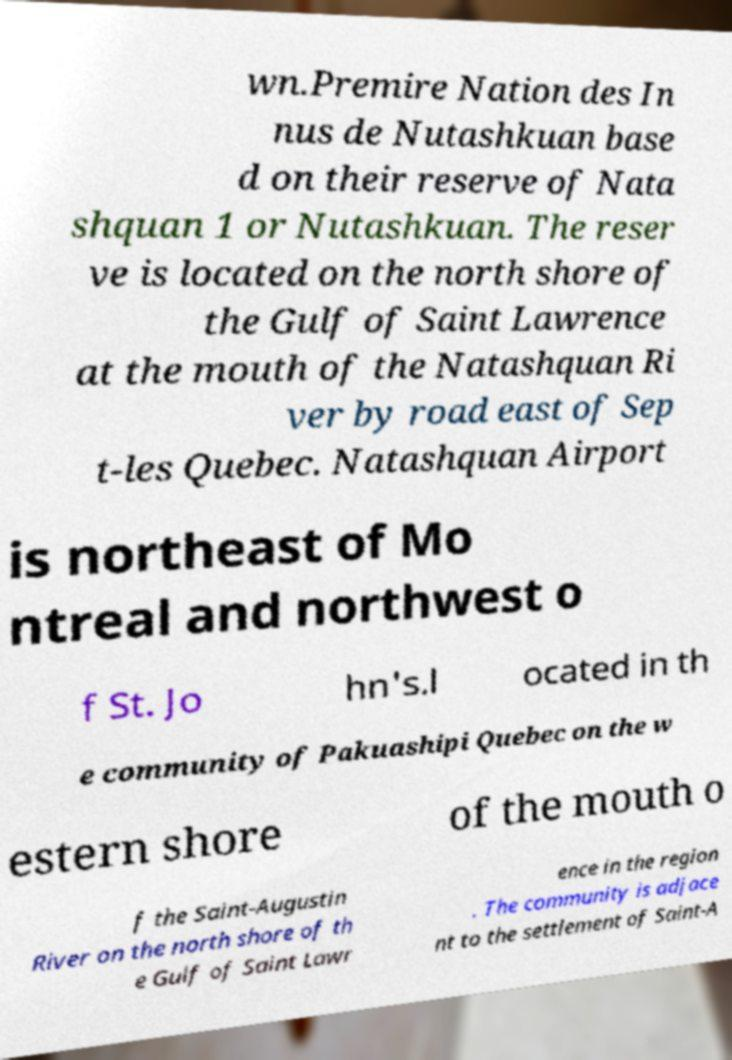Could you assist in decoding the text presented in this image and type it out clearly? wn.Premire Nation des In nus de Nutashkuan base d on their reserve of Nata shquan 1 or Nutashkuan. The reser ve is located on the north shore of the Gulf of Saint Lawrence at the mouth of the Natashquan Ri ver by road east of Sep t-les Quebec. Natashquan Airport is northeast of Mo ntreal and northwest o f St. Jo hn's.l ocated in th e community of Pakuashipi Quebec on the w estern shore of the mouth o f the Saint-Augustin River on the north shore of th e Gulf of Saint Lawr ence in the region . The community is adjace nt to the settlement of Saint-A 